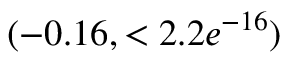<formula> <loc_0><loc_0><loc_500><loc_500>( - 0 . 1 6 , < 2 . 2 e ^ { - 1 6 } )</formula> 